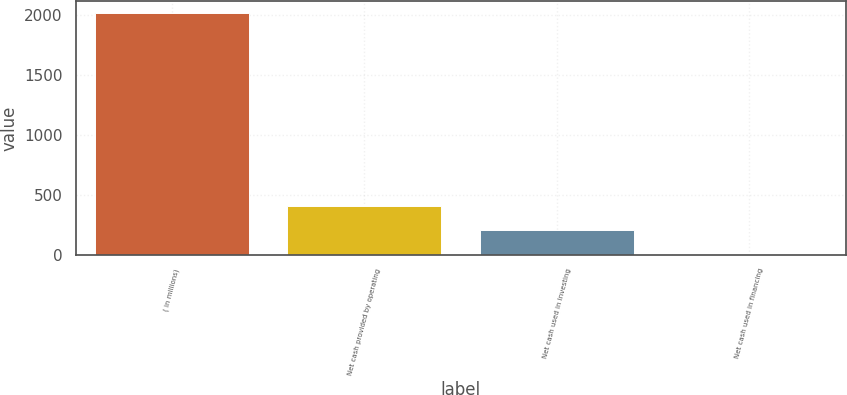Convert chart to OTSL. <chart><loc_0><loc_0><loc_500><loc_500><bar_chart><fcel>( in millions)<fcel>Net cash provided by operating<fcel>Net cash used in investing<fcel>Net cash used in financing<nl><fcel>2012<fcel>405.12<fcel>204.26<fcel>3.4<nl></chart> 